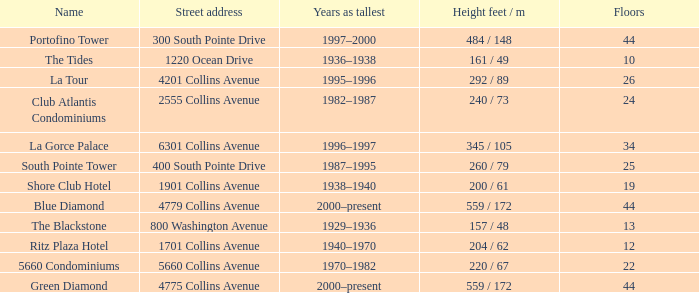How many years was the building with 24 floors the tallest? 1982–1987. 